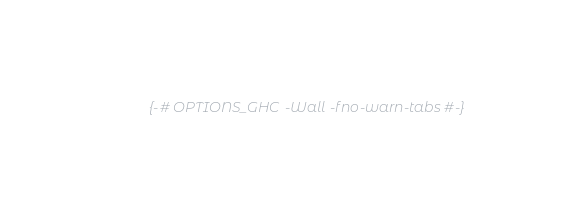Convert code to text. <code><loc_0><loc_0><loc_500><loc_500><_Haskell_>{-# OPTIONS_GHC -Wall -fno-warn-tabs #-}
</code> 